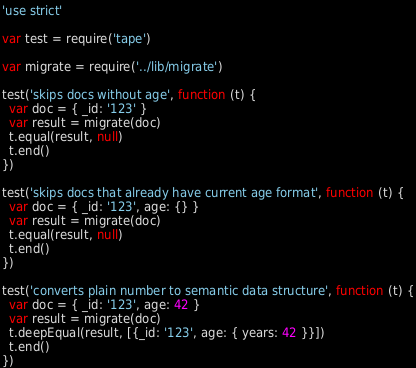<code> <loc_0><loc_0><loc_500><loc_500><_JavaScript_>'use strict'

var test = require('tape')

var migrate = require('../lib/migrate')

test('skips docs without age', function (t) {
  var doc = { _id: '123' }
  var result = migrate(doc)
  t.equal(result, null)
  t.end()
})

test('skips docs that already have current age format', function (t) {
  var doc = { _id: '123', age: {} }
  var result = migrate(doc)
  t.equal(result, null)
  t.end()
})

test('converts plain number to semantic data structure', function (t) {
  var doc = { _id: '123', age: 42 }
  var result = migrate(doc)
  t.deepEqual(result, [{_id: '123', age: { years: 42 }}])
  t.end()
})
</code> 